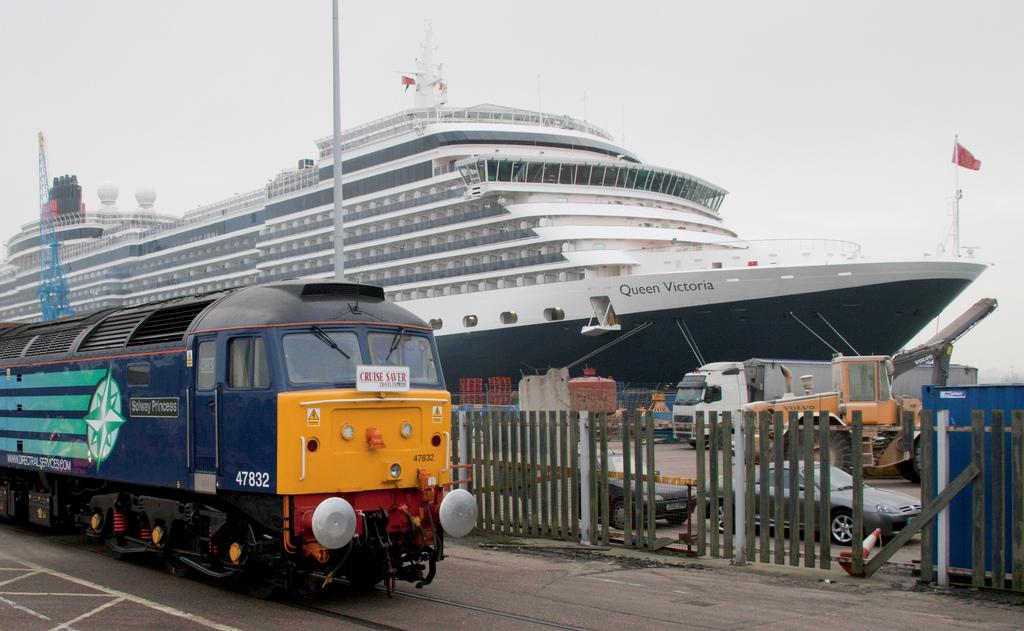Question: what color is the train?
Choices:
A. Orange, brown, purple, and white.
B. Pink, blue, teal, yellow, and charcoal.
C. Blue, yellow, red, black, aqua, and silver.
D. Navy, burnt umber, sienna, blue, and lavender.
Answer with the letter. Answer: C Question: who drives the train?
Choices:
A. The engineer.
B. The conductor.
C. The engines.
D. The driver.
Answer with the letter. Answer: B Question: where is this scene?
Choices:
A. On a beach.
B. On a dock.
C. On the ocean.
D. On a lake.
Answer with the letter. Answer: B Question: what is in the water?
Choices:
A. A buoy.
B. A ship.
C. An otter.
D. A barge.
Answer with the letter. Answer: B Question: what color is the flags on the front of the ship?
Choices:
A. Blue.
B. White.
C. Black.
D. Red.
Answer with the letter. Answer: D Question: what does the train run on?
Choices:
A. Tracks.
B. Oil.
C. Gas.
D. Coal.
Answer with the letter. Answer: A Question: what is the name of the ship?
Choices:
A. Santa Maria.
B. Queen victoria.
C. HMY Britannia.
D. Achille Lauro.
Answer with the letter. Answer: B Question: who runs the boat?
Choices:
A. The pirate.
B. The captain.
C. The crew.
D. The scallywags.
Answer with the letter. Answer: B Question: what is in the foreground?
Choices:
A. A car.
B. A bike.
C. An ATV.
D. A train.
Answer with the letter. Answer: D Question: what does the train have?
Choices:
A. Circular, metal bumpers.
B. A caboose.
C. A bright light.
D. A loud horn.
Answer with the letter. Answer: A Question: what color is the panel on the front of the train?
Choices:
A. Red.
B. Yellow.
C. Orange.
D. Green.
Answer with the letter. Answer: C Question: what is wrong with the fence?
Choices:
A. There are many areas of rotting wood.
B. There is a lack of balance between slats.
C. The base of it is uneven.
D. There are several panels missing.
Answer with the letter. Answer: D Question: what's wrong with the fence?
Choices:
A. It's the wrong color.
B. It's thw wrong material.
C. Needs repair.
D. It's in the wrong spot.
Answer with the letter. Answer: C Question: what color flag does the ship have?
Choices:
A. Red.
B. Blue and white.
C. Yellow.
D. Green.
Answer with the letter. Answer: A Question: what are there many of in the image?
Choices:
A. People.
B. Birds.
C. Vehicles.
D. Planes.
Answer with the letter. Answer: C Question: what is red on the ship?
Choices:
A. The life jacket.
B. The flag.
C. The paint.
D. The fishing pole.
Answer with the letter. Answer: B Question: where is the train running?
Choices:
A. Next to the ship.
B. Next to the tracks.
C. Next to the station.
D. Near the tucks.
Answer with the letter. Answer: A 